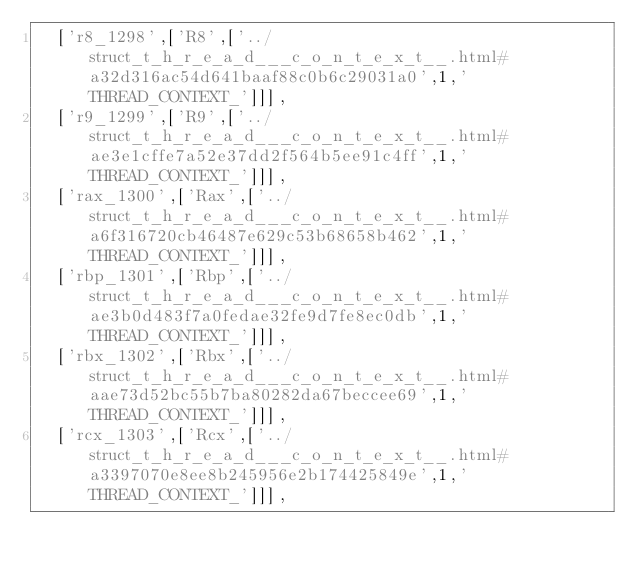<code> <loc_0><loc_0><loc_500><loc_500><_JavaScript_>  ['r8_1298',['R8',['../struct_t_h_r_e_a_d___c_o_n_t_e_x_t__.html#a32d316ac54d641baaf88c0b6c29031a0',1,'THREAD_CONTEXT_']]],
  ['r9_1299',['R9',['../struct_t_h_r_e_a_d___c_o_n_t_e_x_t__.html#ae3e1cffe7a52e37dd2f564b5ee91c4ff',1,'THREAD_CONTEXT_']]],
  ['rax_1300',['Rax',['../struct_t_h_r_e_a_d___c_o_n_t_e_x_t__.html#a6f316720cb46487e629c53b68658b462',1,'THREAD_CONTEXT_']]],
  ['rbp_1301',['Rbp',['../struct_t_h_r_e_a_d___c_o_n_t_e_x_t__.html#ae3b0d483f7a0fedae32fe9d7fe8ec0db',1,'THREAD_CONTEXT_']]],
  ['rbx_1302',['Rbx',['../struct_t_h_r_e_a_d___c_o_n_t_e_x_t__.html#aae73d52bc55b7ba80282da67beccee69',1,'THREAD_CONTEXT_']]],
  ['rcx_1303',['Rcx',['../struct_t_h_r_e_a_d___c_o_n_t_e_x_t__.html#a3397070e8ee8b245956e2b174425849e',1,'THREAD_CONTEXT_']]],</code> 